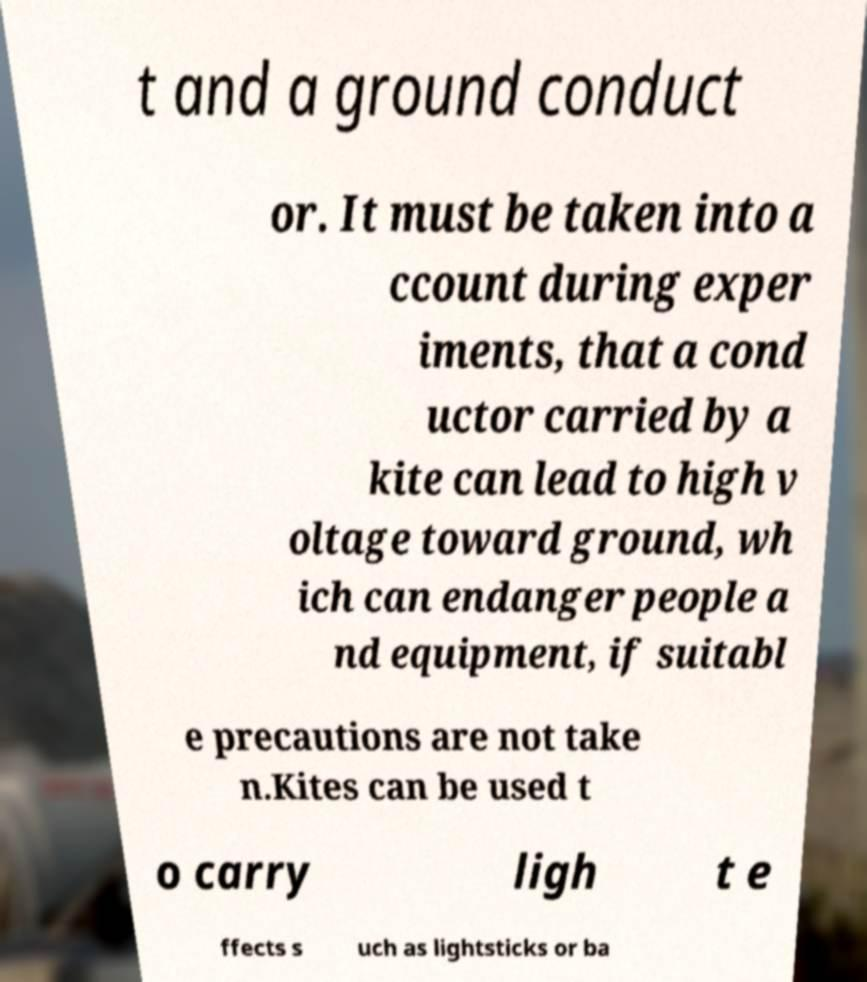Could you extract and type out the text from this image? t and a ground conduct or. It must be taken into a ccount during exper iments, that a cond uctor carried by a kite can lead to high v oltage toward ground, wh ich can endanger people a nd equipment, if suitabl e precautions are not take n.Kites can be used t o carry ligh t e ffects s uch as lightsticks or ba 